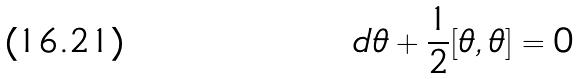Convert formula to latex. <formula><loc_0><loc_0><loc_500><loc_500>d \theta + \frac { 1 } { 2 } [ \theta , \theta ] = 0</formula> 